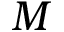<formula> <loc_0><loc_0><loc_500><loc_500>M</formula> 